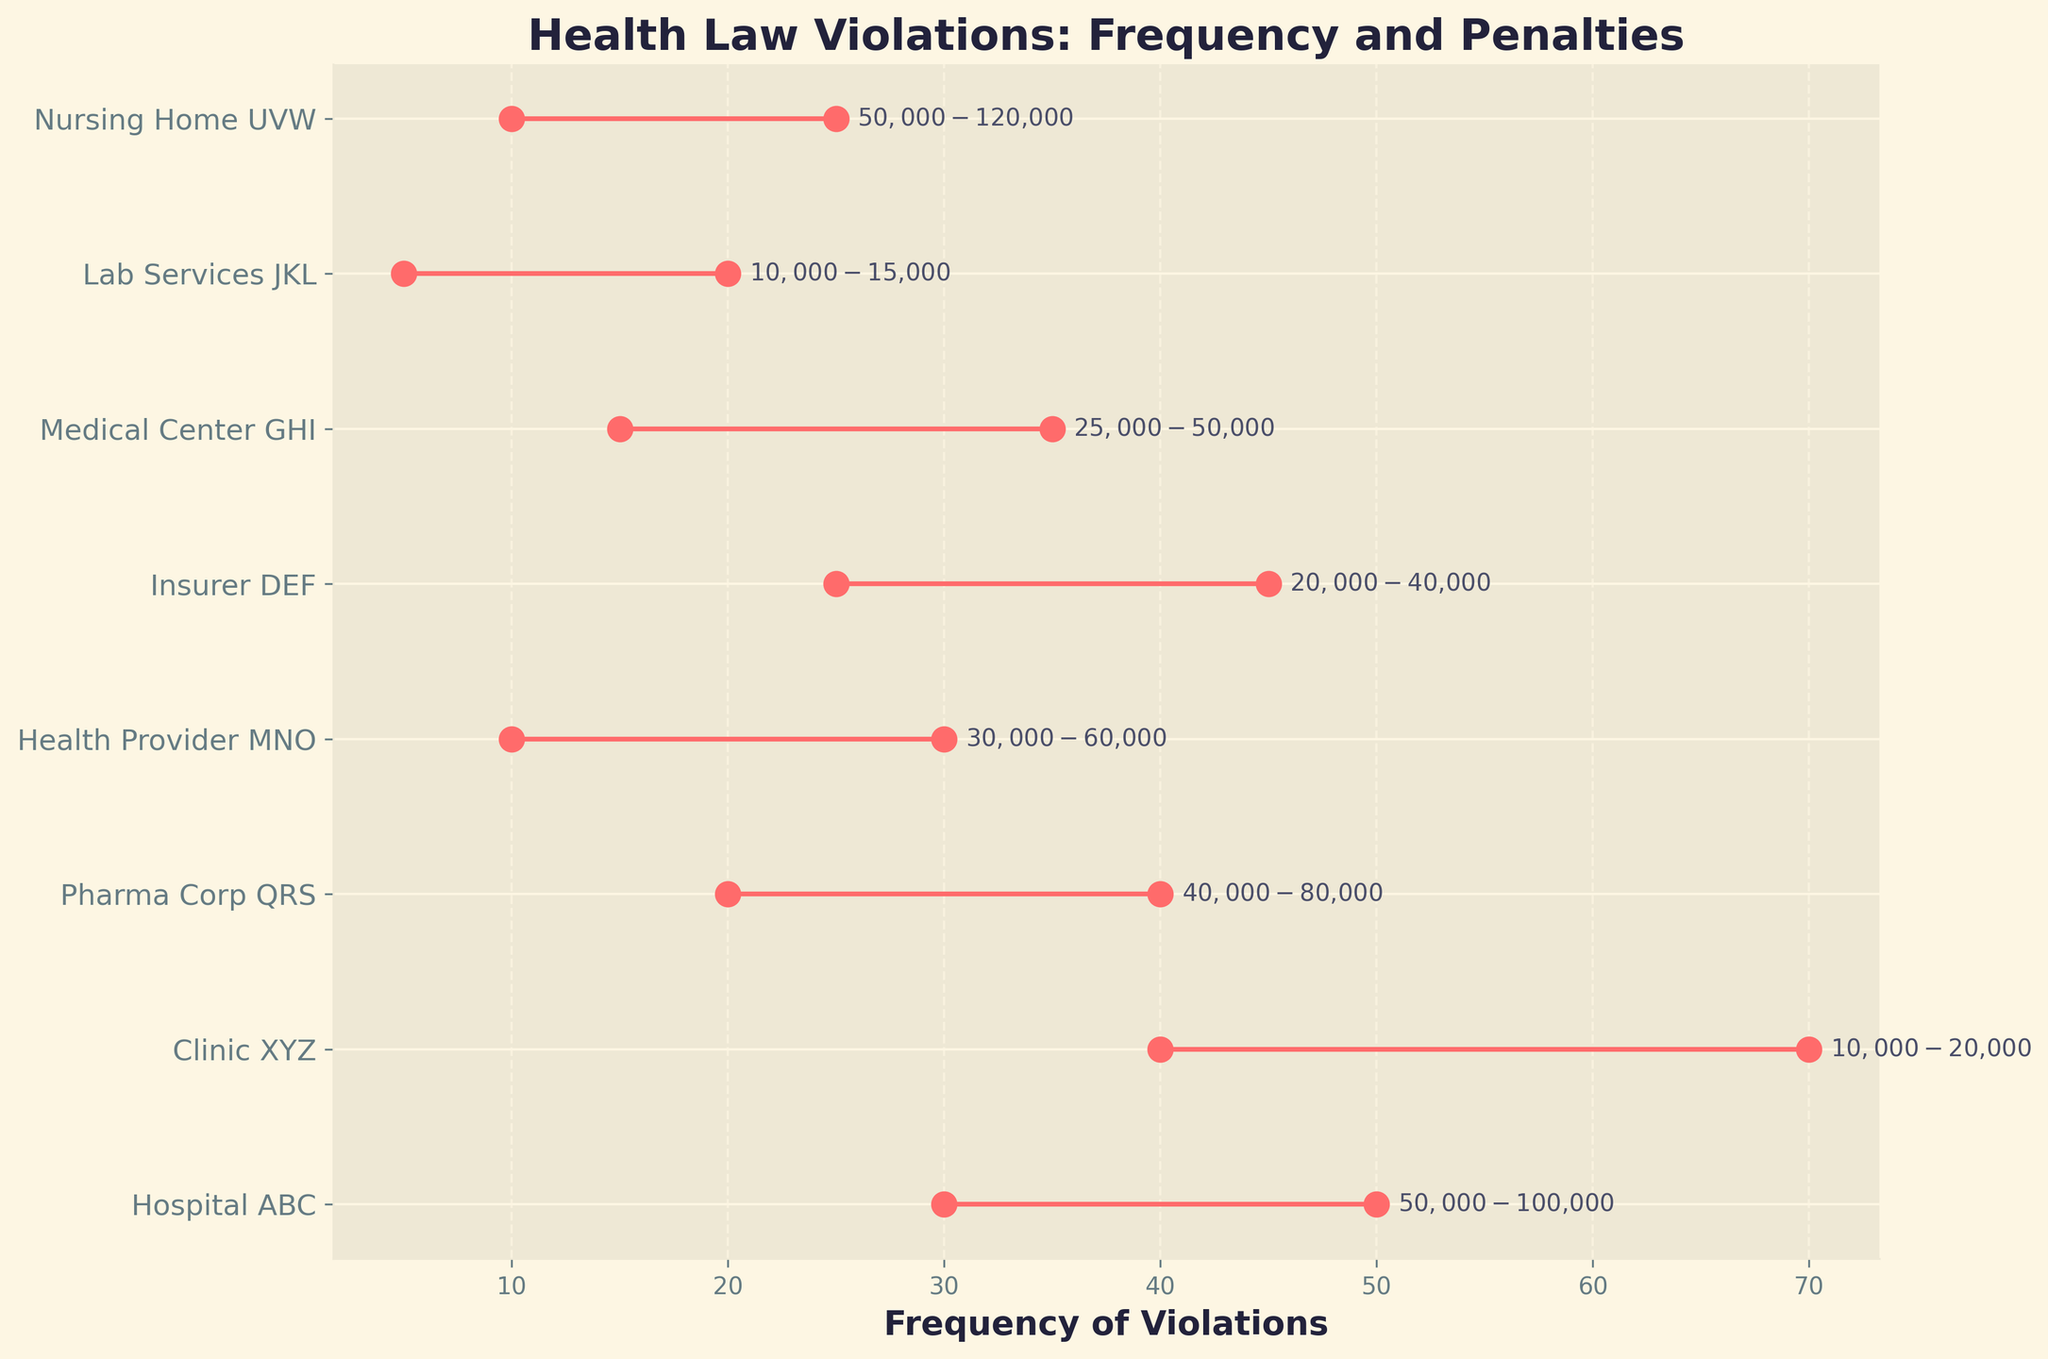What is the title of the plot? The title is located at the top of the plot where it is clearly labeled.
Answer: Health Law Violations: Frequency and Penalties Which entity has the highest maximum frequency of violations? By examining the maximum values on the plot, we can see that Clinic XYZ has the highest maximum frequency with a value of 70.
Answer: Clinic XYZ What is the penalty range for Lab Services JKL's violations? The penalty range is annotated next to the Lab Services JKL data point on the plot. It shows a range of $10,000 to $15,000.
Answer: $10,000-$15,000 Which entity has the smallest range in the frequency of violations? Comparing the ranges visually, Medical Center GHI has the smallest frequency range from 15-35, which is a span of 20.
Answer: Medical Center GHI How many entities have their maximum frequency of violations exceeding 40? By looking at the points on the plot, Clinic XYZ (70), Hospital ABC (50), and Insurer DEF (45) exceed a maximum frequency of 40. Therefore, there are 3 such entities.
Answer: 3 What is the frequency range of the Unlicensed Practice violation for Health Provider MNO? The frequencies are plotted along the x-axis from 10 to 30 for Health Provider MNO.
Answer: 10-30 Which entity has the highest maximum penalty? By looking at the annotations next to the plotted ranges, Nursing Home UVW has the highest maximum penalty, with a value of $120,000.
Answer: Nursing Home UVW What is the average penalty range for False Advertising by Pharma Corp QRS? The penalty range for Pharma Corp QRS is $40,000 to $80,000. Averaging these values: (40,000 + 80,000) / 2 = 60,000.
Answer: $60,000 Which violation has the lowest minimum penalty, and what is that penalty? According to the annotations next to the plotted ranges, the lowest minimum penalty is $10,000, which is associated with the Improper Billing by Clinic XYZ and Failure to Report Test Results by Lab Services JKL.
Answer: $10,000 What is the difference between the maximum penalty of Nursing Home UVW and the minimum penalty of Hospital ABC? The maximum penalty for Nursing Home UVW is $120,000, and the minimum penalty for Hospital ABC is $50,000. The difference is: $120,000 - $50,000 = $70,000.
Answer: $70,000 